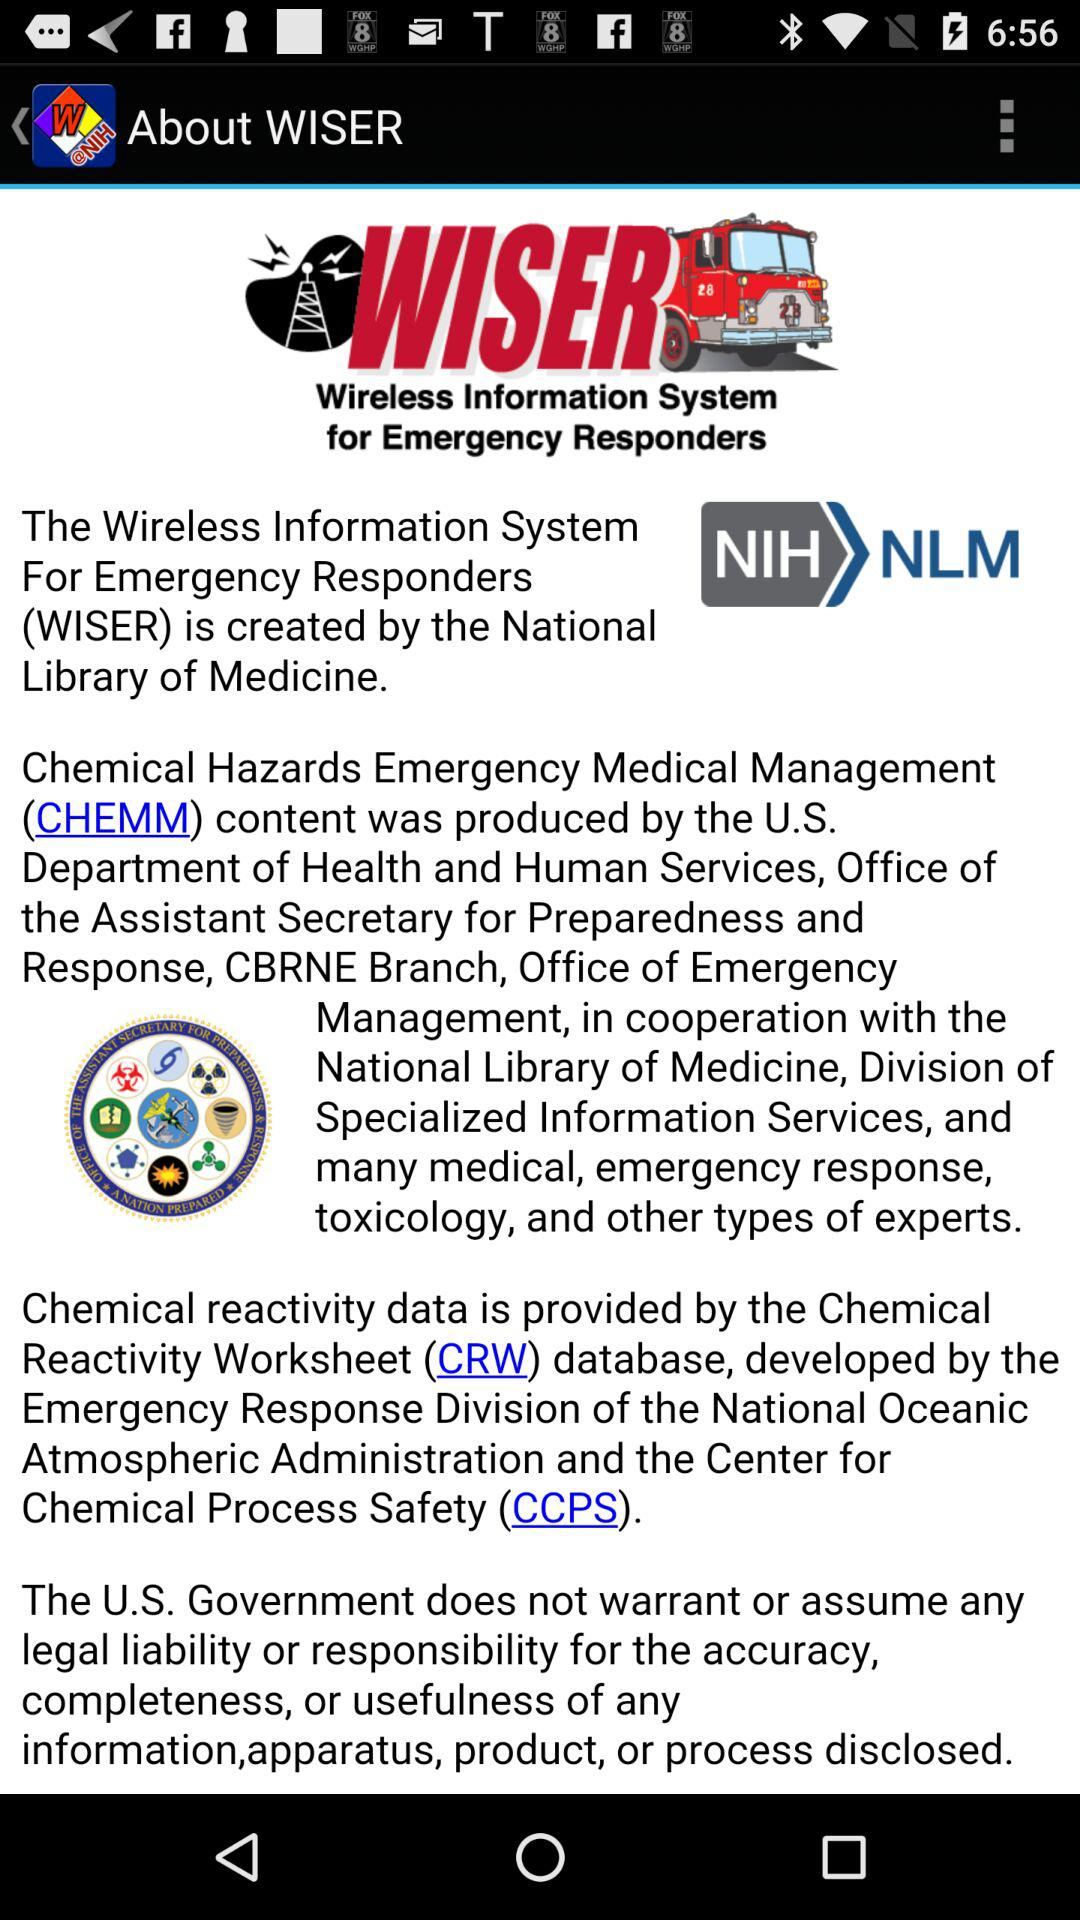What is the app name? The app name is "WISER". 